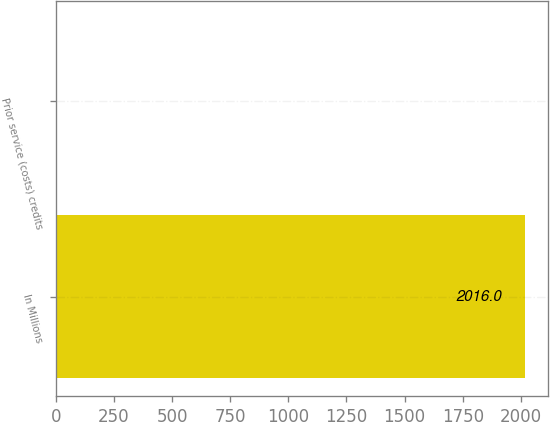Convert chart. <chart><loc_0><loc_0><loc_500><loc_500><bar_chart><fcel>In Millions<fcel>Prior service (costs) credits<nl><fcel>2016<fcel>6.8<nl></chart> 